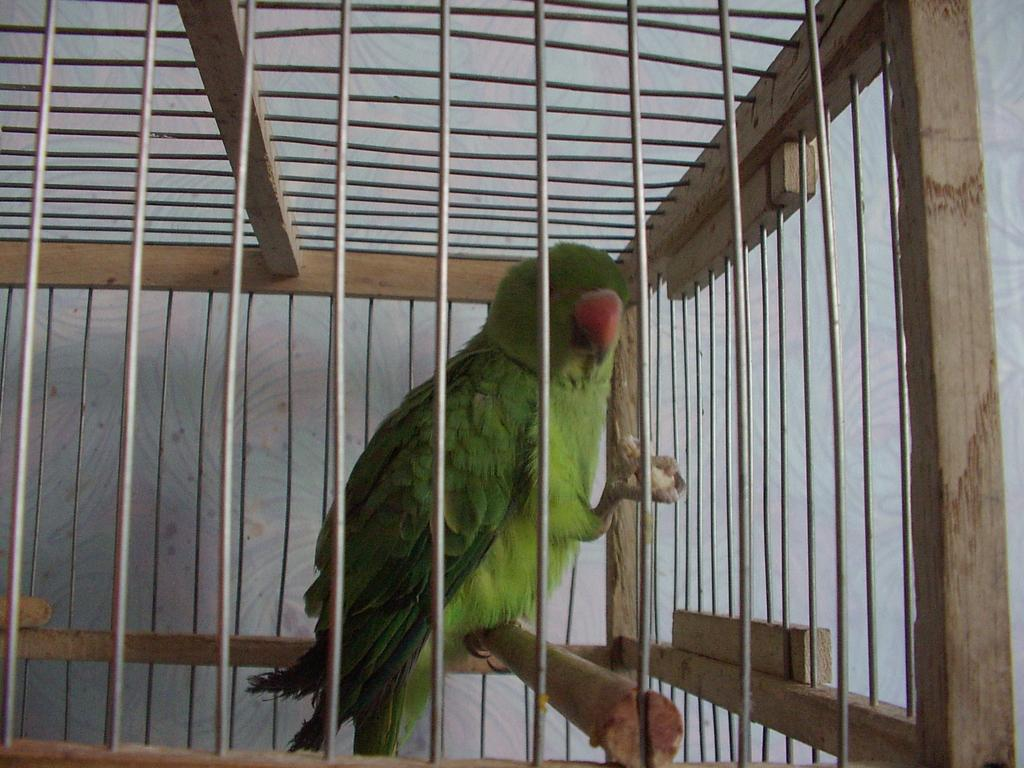What type of animal is in the image? There is a parrot in the image. Where is the parrot located? The parrot is in a cage. What might be behind the cage? The back side of the cage might be a wall. How does the parrot pull the kite in the image? There is no kite present in the image, so the parrot cannot pull a kite. 